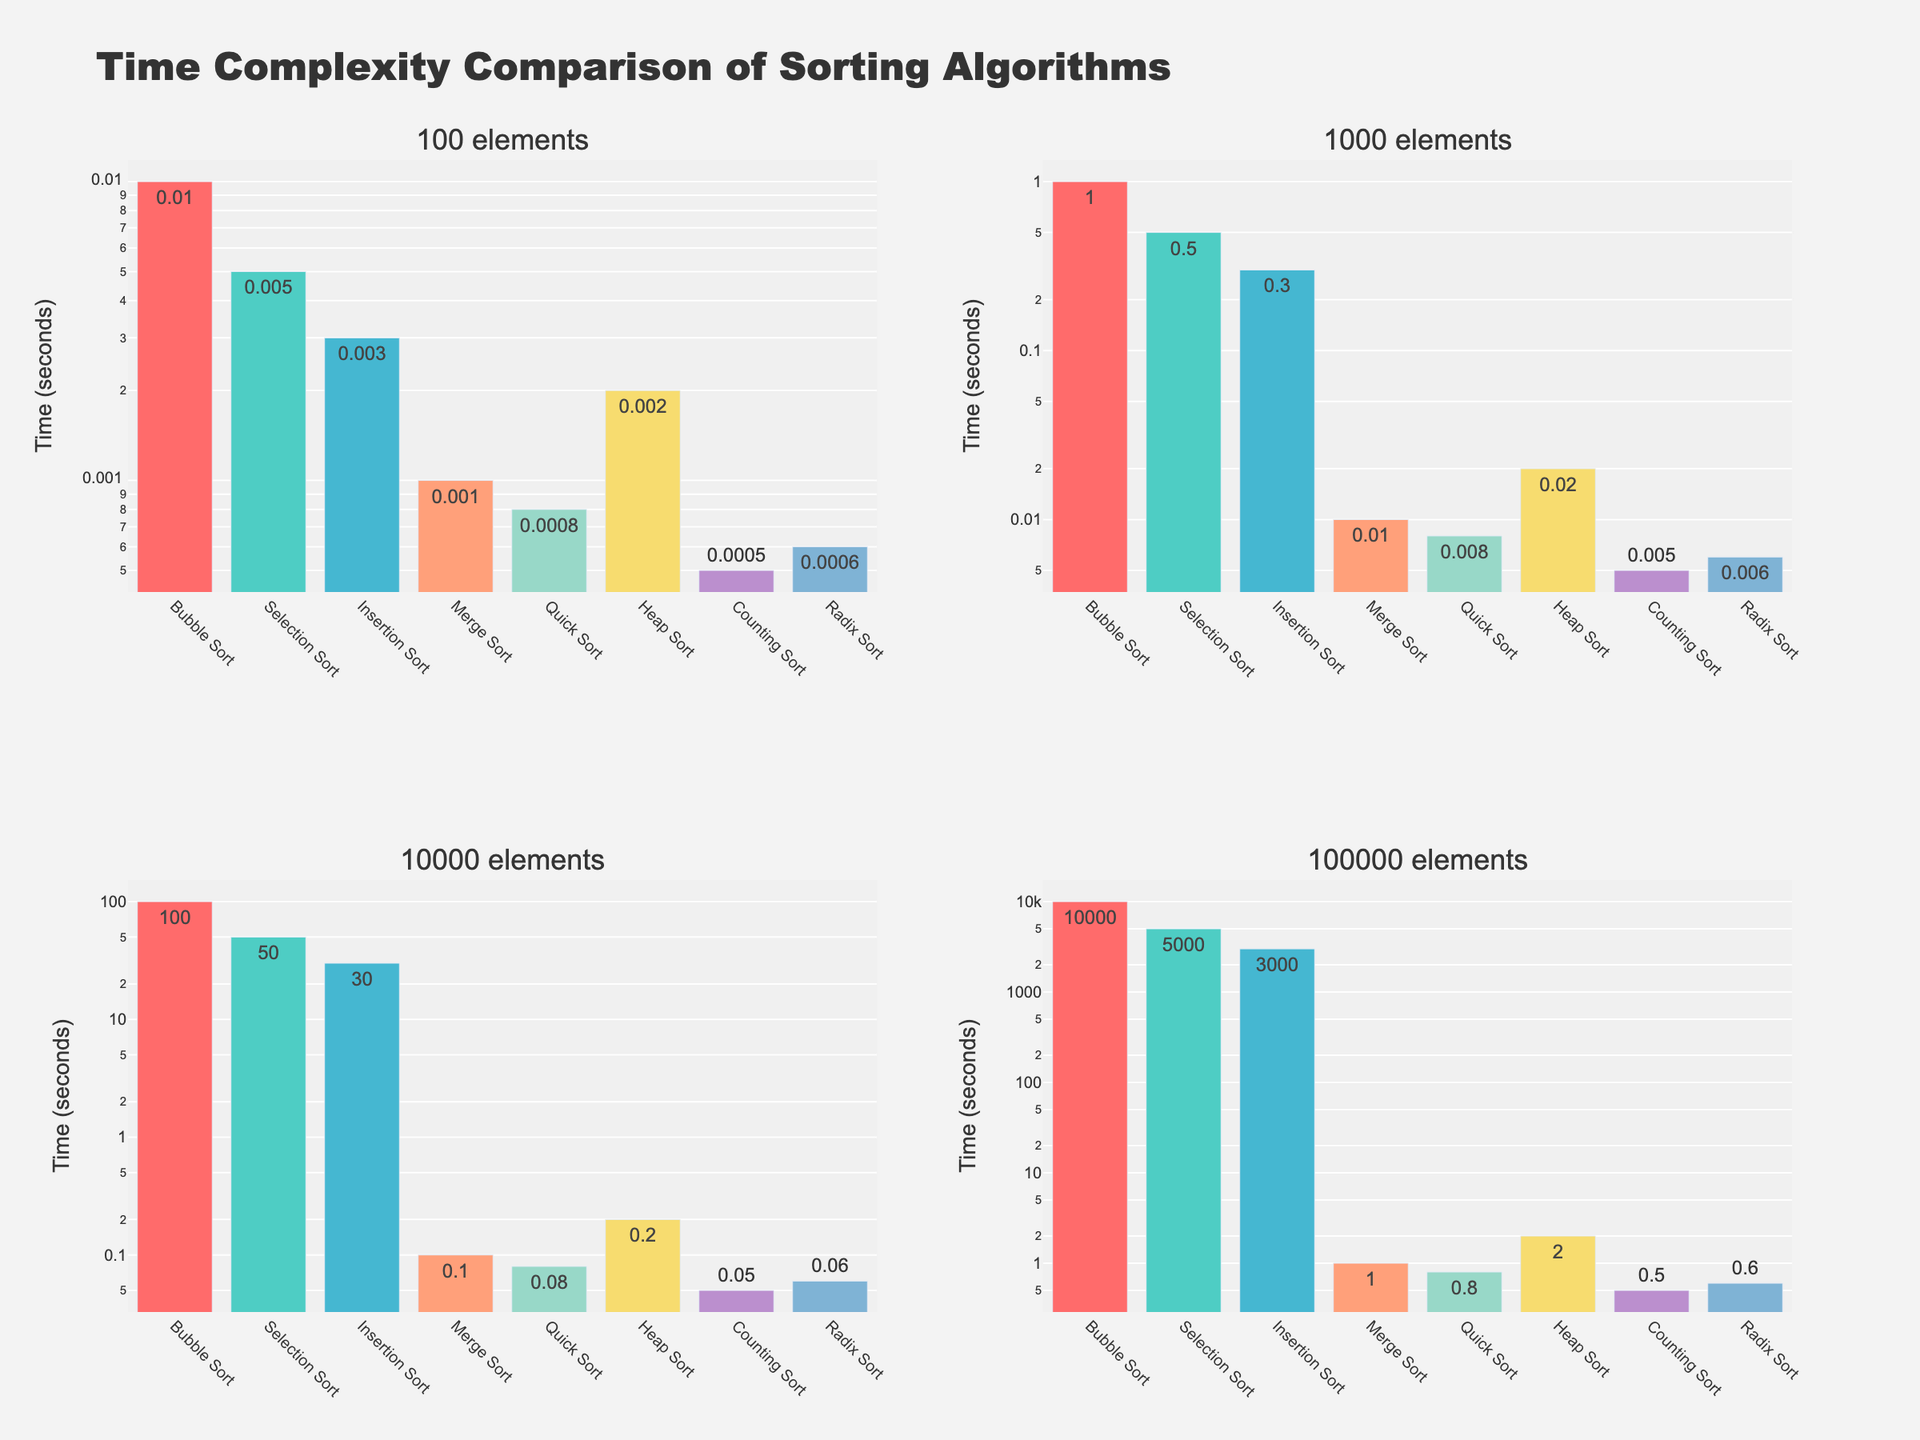What algorithm has the highest time complexity for 100,000 elements? Find the tallest bar in the chart for the 100,000 elements subplot. The tallest bar corresponds to Bubble Sort.
Answer: Bubble Sort Which algorithm performs better at sorting 1,000 elements, Selection Sort or Insertion Sort? Compare the heights of the bars for Selection Sort and Insertion Sort in the 1,000 elements subplot. The bar for Insertion Sort is lower.
Answer: Insertion Sort How much faster is Counting Sort compared to Merge Sort for 1,000 elements? Look at the heights of the bars for Counting Sort and Merge Sort in the 1,000 elements subplot. Counting Sort is faster. The time for Counting Sort is 0.005 seconds and for Merge Sort is 0.01 seconds. Subtract these values: 0.01 - 0.005 = 0.005 seconds.
Answer: 0.005 seconds What is the average time complexity of Quick Sort across all input sizes? Sum the times for Quick Sort across all input sizes: 0.0008 + 0.008 + 0.08 + 0.8 = 0.8888 seconds. Divide by the number of input sizes: 0.8888 / 4 = 0.2222 seconds.
Answer: 0.2222 seconds Which algorithm has the lowest time complexity for 10,000 elements? Find the shortest bar in the chart for the 10,000 elements subplot. The shortest bar corresponds to Counting Sort.
Answer: Counting Sort Compare the time complexity of Bubble Sort and Radix Sort for 100 elements. Look at the heights of the bars for Bubble Sort and Radix Sort in the 100 elements subplot. The bar for Radix Sort is shorter, indicating Radix Sort is faster.
Answer: Radix Sort What is the difference in time complexity between Heap Sort and Merge Sort for 100,000 elements? Compare the heights of the bars for Heap Sort and Merge Sort in the 100,000 elements subplot. The time for Heap Sort is 2.0 seconds, and for Merge Sort is 1.0 seconds. Subtract these values: 2.0 - 1.0 = 1.0 second.
Answer: 1.0 second Of the algorithms shown, which one shows the least variation in time complexity across different input sizes? Compare the bars of each algorithm across all input sizes. Counting Sort has bars that increase proportionally without drastic variations.
Answer: Counting Sort What is the combined total time complexity for Bubble Sort and Quick Sort for 100 elements? Add the times for Bubble Sort and Quick Sort for 100 elements: 0.01 + 0.0008 = 0.0108 seconds.
Answer: 0.0108 seconds How do the performances of Insertion Sort and Heap Sort compare for 10,000 elements? Compare the heights of the bars for Insertion Sort and Heap Sort in the 10,000 elements subplot. The bar for Heap Sort is slightly taller, indicating it is slower.
Answer: Insertion Sort 